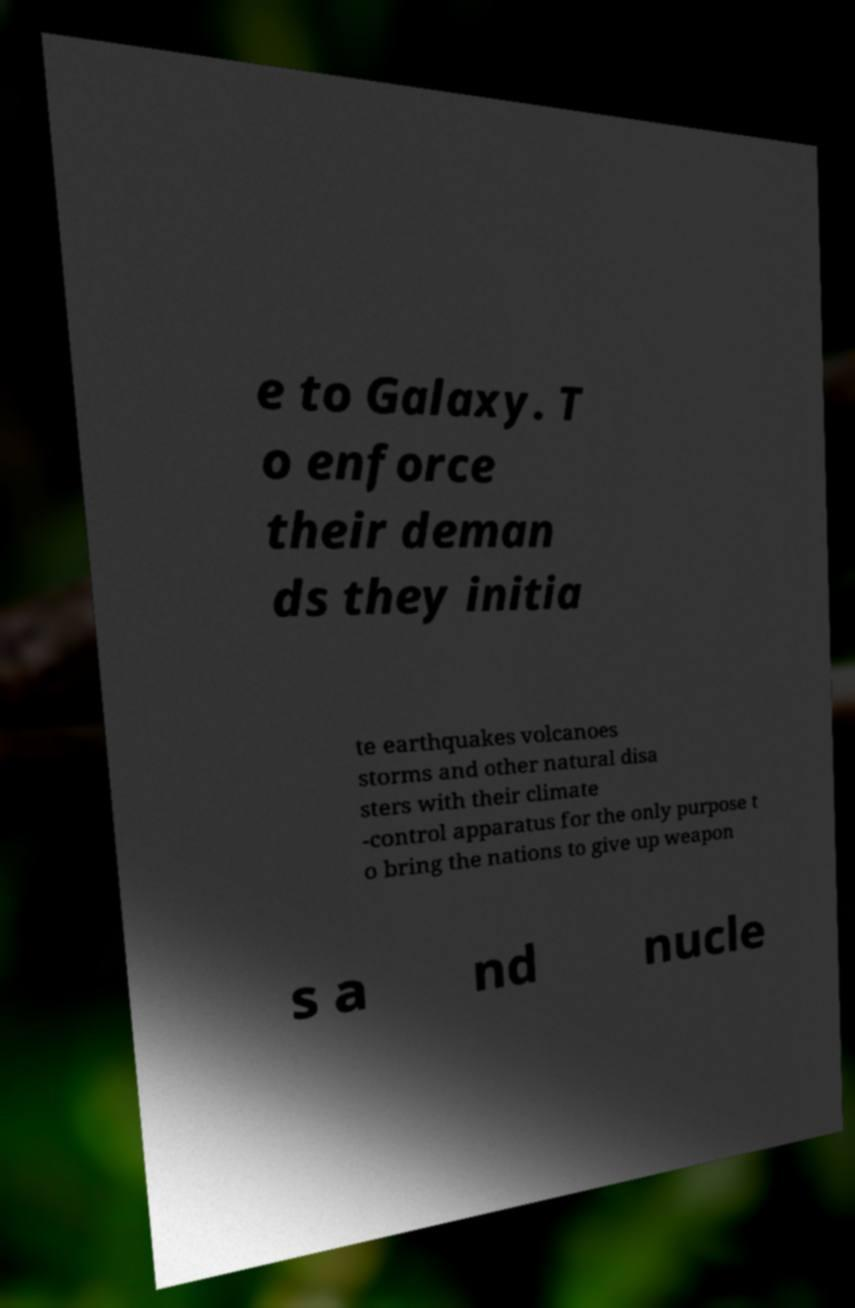Can you accurately transcribe the text from the provided image for me? e to Galaxy. T o enforce their deman ds they initia te earthquakes volcanoes storms and other natural disa sters with their climate -control apparatus for the only purpose t o bring the nations to give up weapon s a nd nucle 